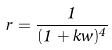<formula> <loc_0><loc_0><loc_500><loc_500>r = \frac { 1 } { ( 1 + k w ) ^ { 4 } }</formula> 